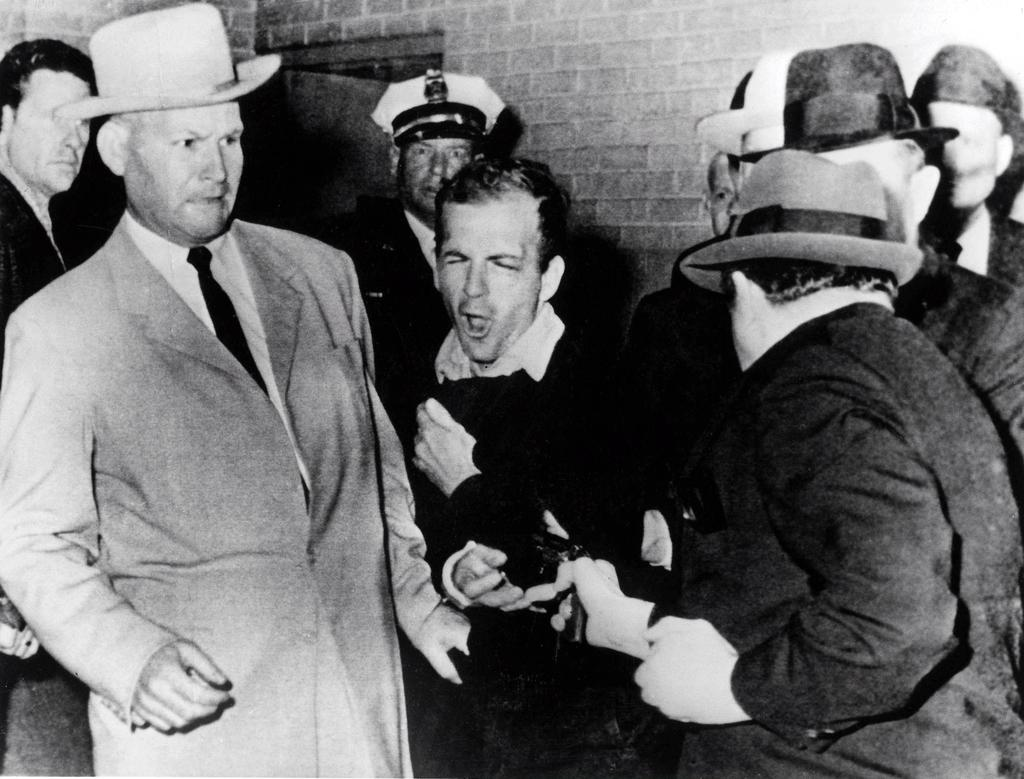How many persons are in the image? There are two persons in the image. Can you describe the man on the left side of the image? The man on the left side is wearing a coat and a tie. What is the man on the right side of the image holding? The man on the right side is holding a pistol in his right hand. What type of music can be heard playing in the background of the image? There is no music present in the image, so it cannot be determined what, if any, music might be heard. 